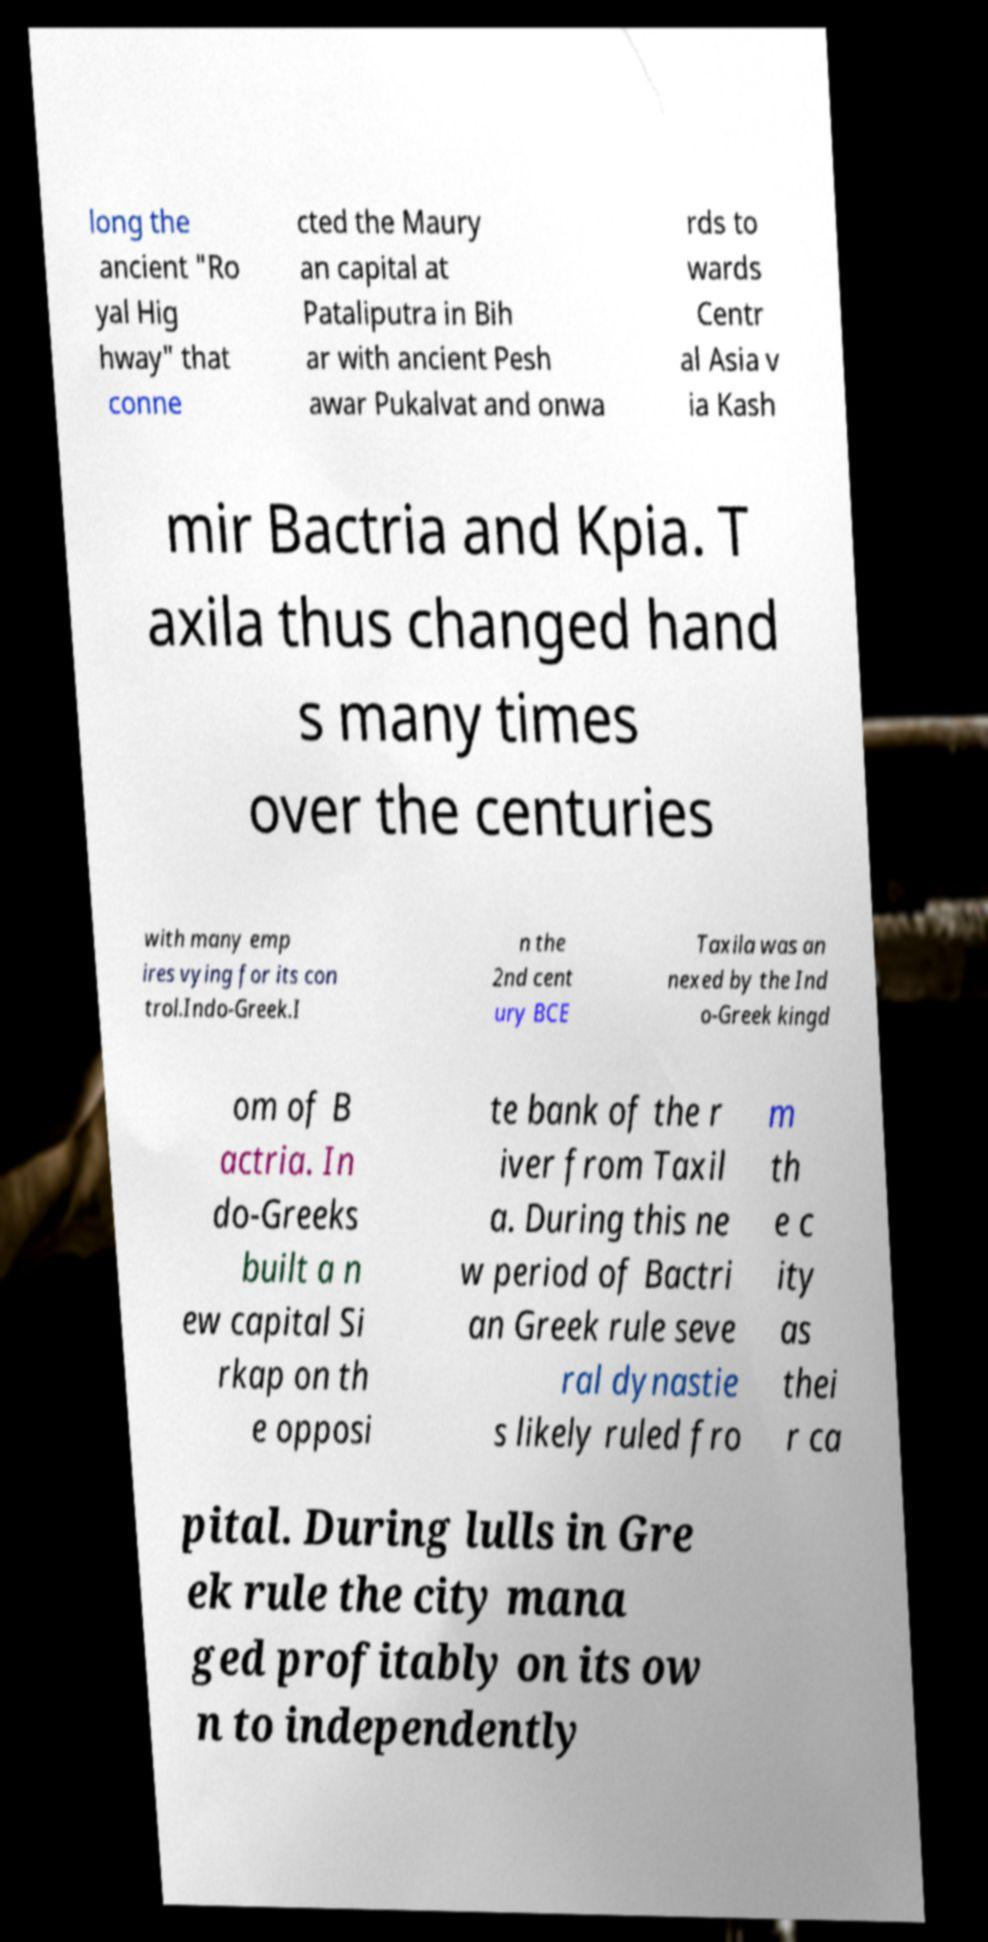There's text embedded in this image that I need extracted. Can you transcribe it verbatim? long the ancient "Ro yal Hig hway" that conne cted the Maury an capital at Pataliputra in Bih ar with ancient Pesh awar Pukalvat and onwa rds to wards Centr al Asia v ia Kash mir Bactria and Kpia. T axila thus changed hand s many times over the centuries with many emp ires vying for its con trol.Indo-Greek.I n the 2nd cent ury BCE Taxila was an nexed by the Ind o-Greek kingd om of B actria. In do-Greeks built a n ew capital Si rkap on th e opposi te bank of the r iver from Taxil a. During this ne w period of Bactri an Greek rule seve ral dynastie s likely ruled fro m th e c ity as thei r ca pital. During lulls in Gre ek rule the city mana ged profitably on its ow n to independently 